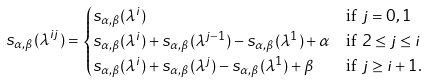<formula> <loc_0><loc_0><loc_500><loc_500>s _ { \alpha , \beta } ( \lambda ^ { i j } ) & = \begin{cases} s _ { \alpha , \beta } ( \lambda ^ { i } ) & \text {if $j=0,1$} \\ s _ { \alpha , \beta } ( \lambda ^ { i } ) + s _ { \alpha , \beta } ( \lambda ^ { j - 1 } ) - s _ { \alpha , \beta } ( \lambda ^ { 1 } ) + \alpha & \text {if $2 \leq j \leq i$} \\ s _ { \alpha , \beta } ( \lambda ^ { i } ) + s _ { \alpha , \beta } ( \lambda ^ { j } ) - s _ { \alpha , \beta } ( \lambda ^ { 1 } ) + \beta & \text {if $j \geq i+1$.} \end{cases}</formula> 